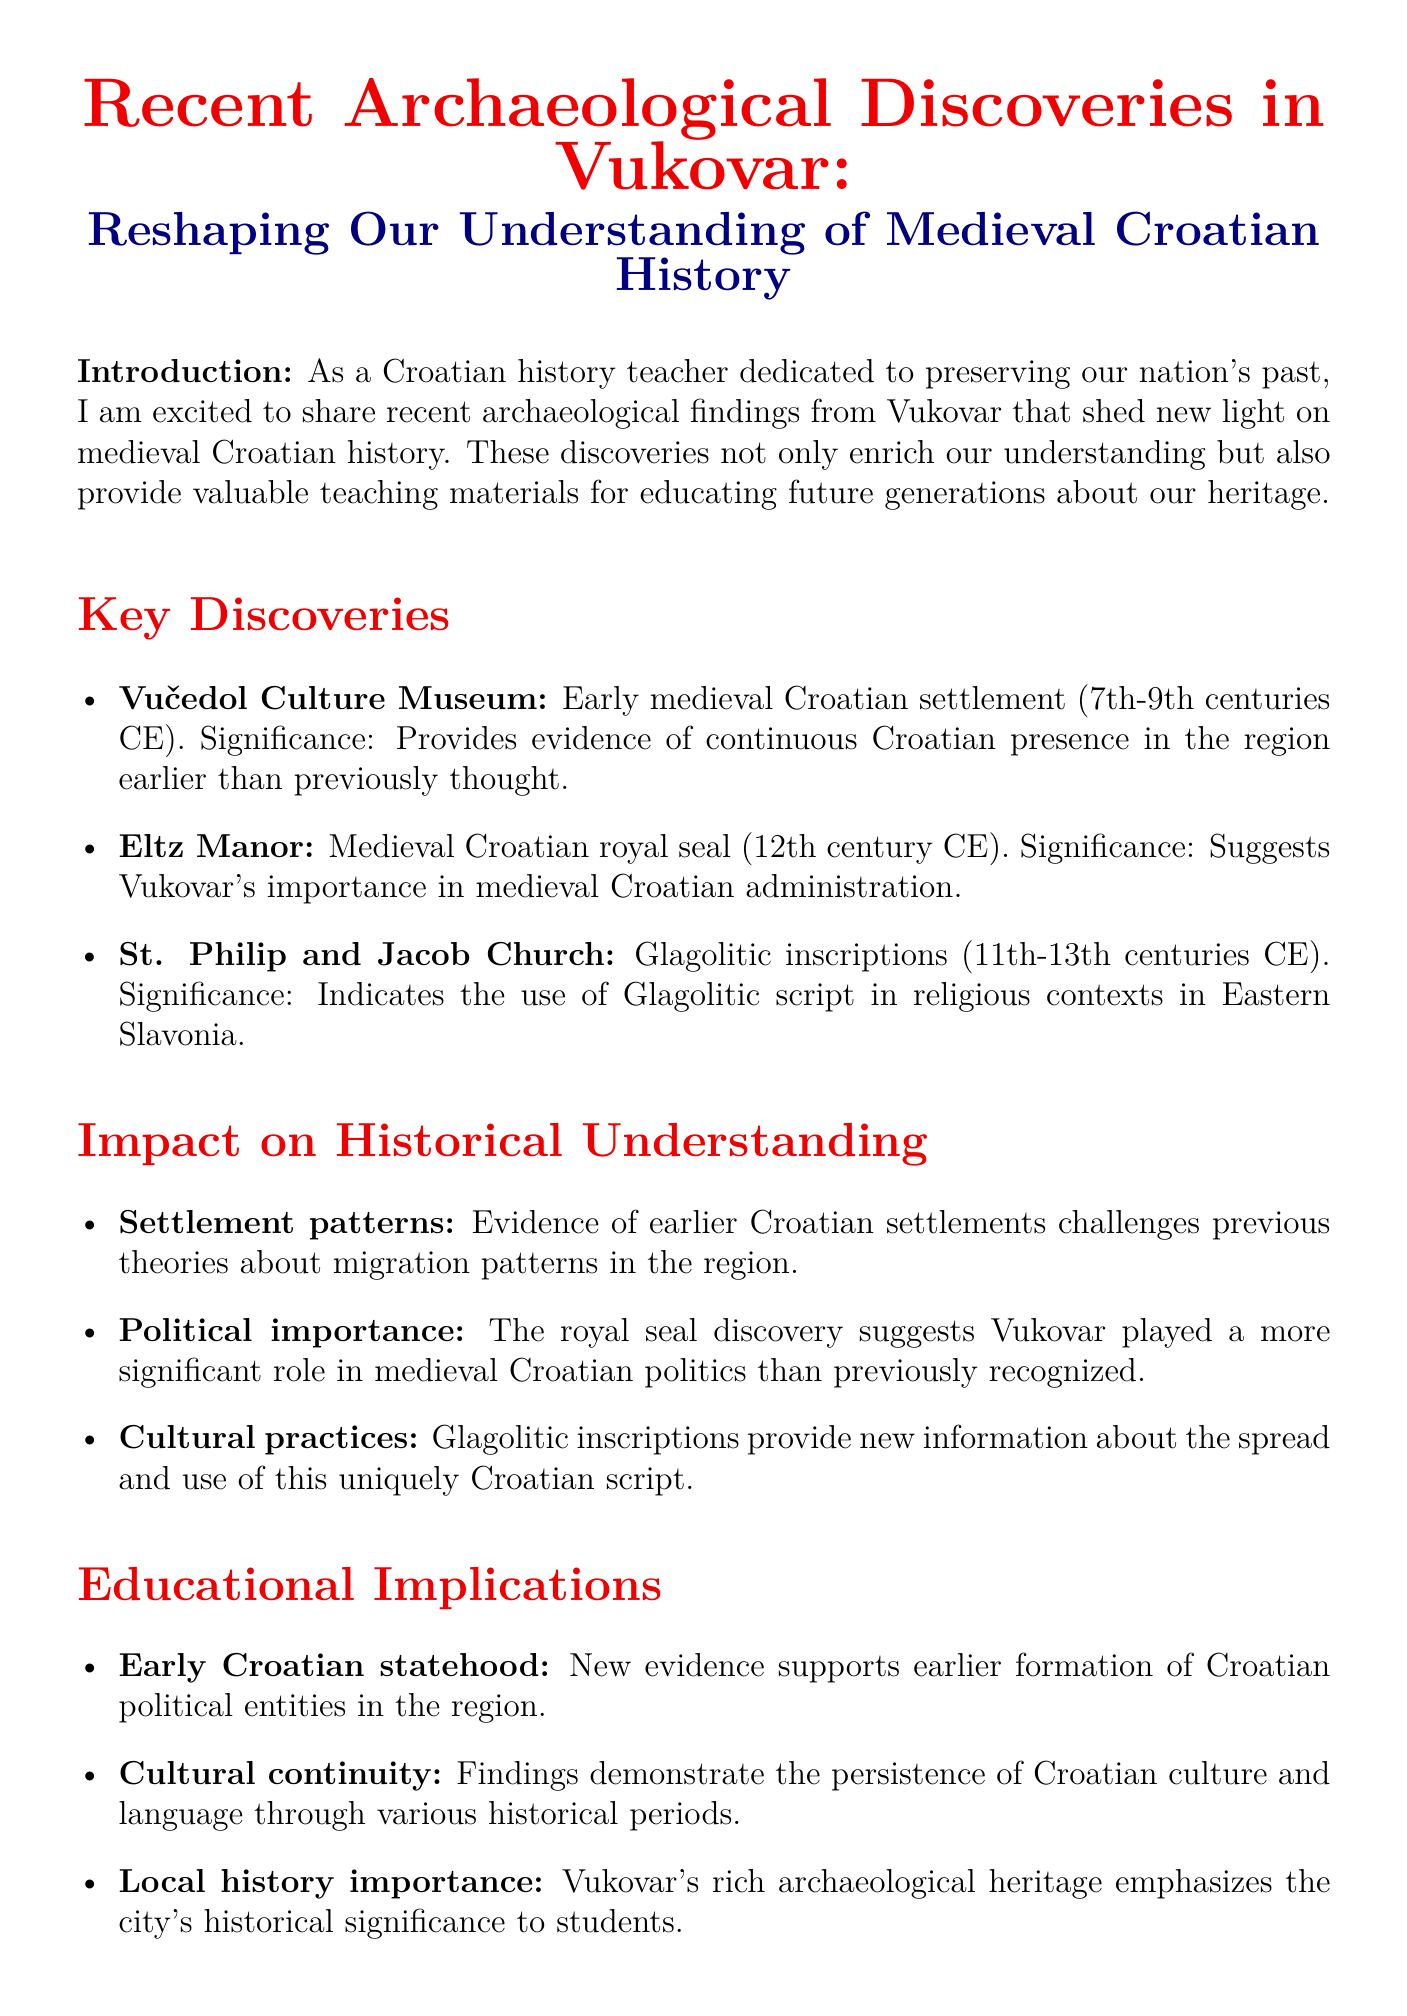What is the main title of the memo? The main title of the memo is the topic outlined in the document header, which summarizes the focus of the findings.
Answer: Recent Archaeological Discoveries in Vukovar: Reshaping Our Understanding of Medieval Croatian History What period do the findings from Vučedol Culture Museum date back to? The document specifies the era related to the early medieval Croatian settlement discovered at this site, providing a timeframe for the significance of the findings.
Answer: 7th-9th centuries CE What was discovered at Eltz Manor? The type of artifact found at Eltz Manor is described in the document as significant for understanding medieval Croatian politics, leading to insight into Vukovar's historical context.
Answer: Medieval Croatian royal seal What type of script is mentioned in relation to St. Philip and Jacob Church? The significance of the findings at St. Philip and Jacob Church includes information about a specific type of writing used in Eastern Slavonia, illustrating cultural practices of the time.
Answer: Glagolitic inscriptions What new insight is provided about settlement patterns? The document presents information that alters previous theories about Croatian migration, emphasizing the implications of the archaeological findings on historical understanding.
Answer: Challenges previous theories about migration patterns What does the discovery of the royal seal suggest about Vukovar? The document links the artifact to significant implications regarding Vukovar's role in governance during the medieval period, indicating its administrative importance.
Answer: Played a more significant role in medieval Croatian politics Which topic is relevant to the findings concerning early Croatian statehood? The relevance aspect focuses on the emerging political entities indicated by the new archaeological evidence, reflecting a crucial aspect of Croatian history alignment.
Answer: New evidence supports earlier formation of Croatian political entities in the region What are the potential areas for future research mentioned? The memo outlines suggested directions for further archaeological inquiry, intended to deepen the understanding of Vukovar’s historical narrative and cultural significance.
Answer: Further excavations around Eltz Manor, comparative studies with other Slavonian sites, analysis of material culture for trade connections What are educators encouraged to do with these findings? The conclusion of the document emphasizes the active role that educators should take in relation to the recent discoveries, promoting the integration of the discoveries into educational frameworks.
Answer: Incorporate these findings into our curriculum 